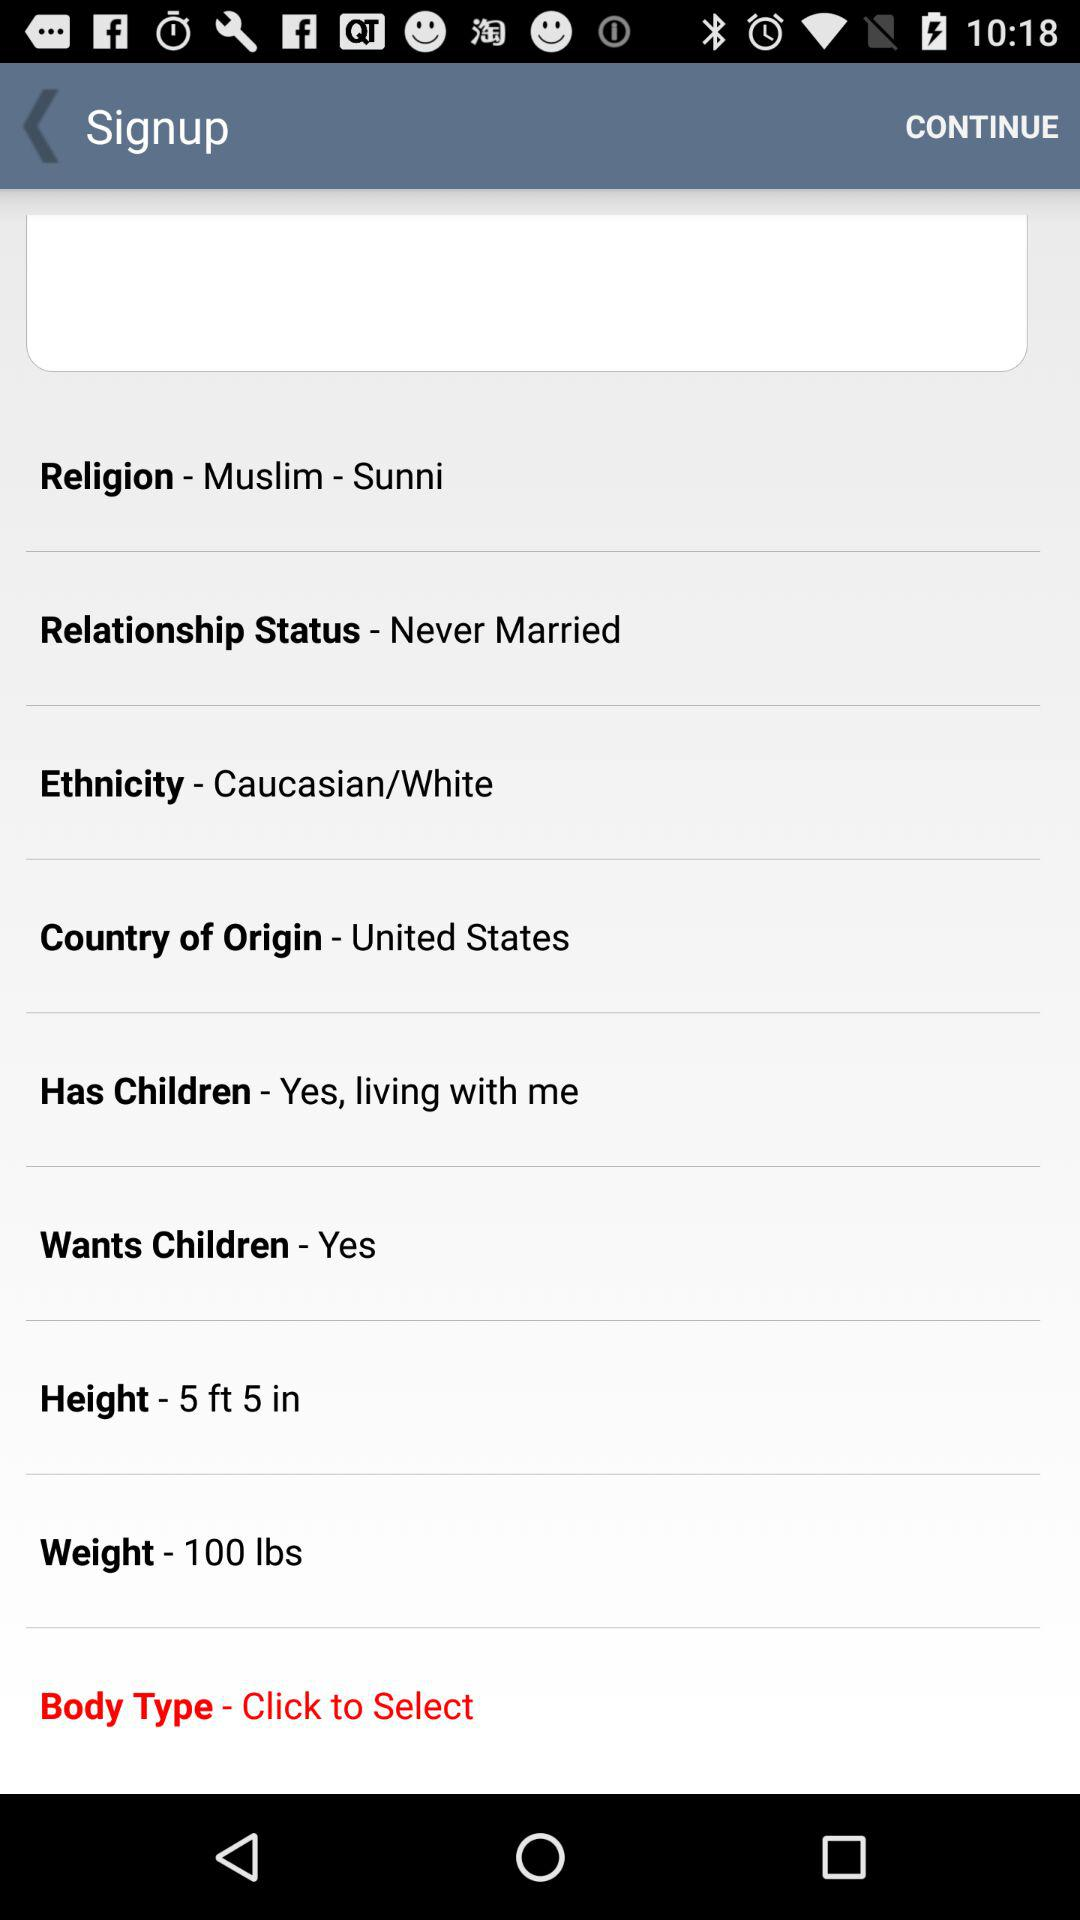What is the country of origin? The country of origin is the United States. 